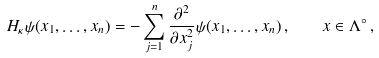Convert formula to latex. <formula><loc_0><loc_0><loc_500><loc_500>H _ { \kappa } \psi ( x _ { 1 } , \dots , x _ { n } ) = - \sum _ { j = 1 } ^ { n } \frac { \partial ^ { 2 } } { \partial x _ { j } ^ { 2 } } \psi ( x _ { 1 } , \dots , x _ { n } ) \, , \quad x \in \Lambda ^ { \circ } \, ,</formula> 